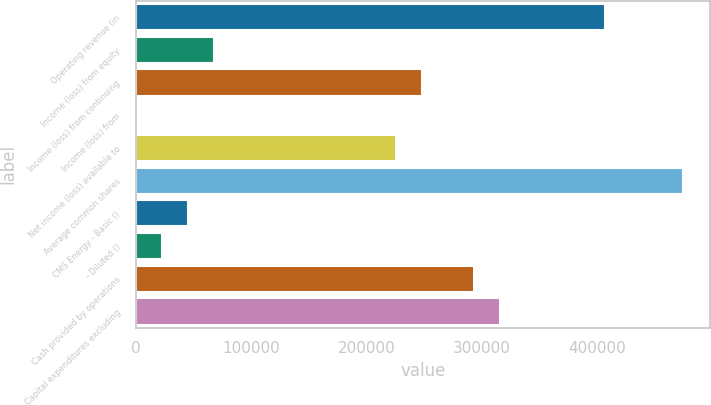Convert chart. <chart><loc_0><loc_0><loc_500><loc_500><bar_chart><fcel>Operating revenue (in<fcel>Income (loss) from equity<fcel>Income (loss) from continuing<fcel>Income (loss) from<fcel>Net income (loss) available to<fcel>Average common shares<fcel>CMS Energy - Basic ()<fcel>- Diluted ()<fcel>Cash provided by operations<fcel>Capital expenditures excluding<nl><fcel>406207<fcel>67702<fcel>248238<fcel>1<fcel>225671<fcel>473908<fcel>45135<fcel>22568<fcel>293372<fcel>315939<nl></chart> 